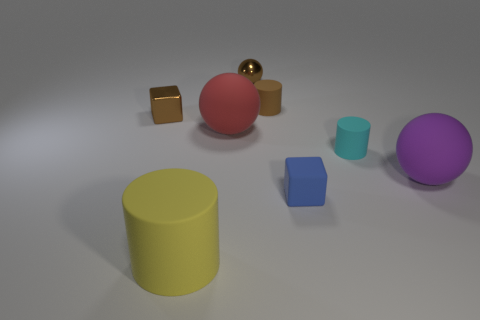Subtract all big red balls. How many balls are left? 2 Subtract 1 cylinders. How many cylinders are left? 2 Add 1 tiny brown rubber cylinders. How many objects exist? 9 Subtract all blue cylinders. Subtract all cyan spheres. How many cylinders are left? 3 Subtract all cubes. How many objects are left? 6 Add 6 big yellow metallic cylinders. How many big yellow metallic cylinders exist? 6 Subtract 0 green blocks. How many objects are left? 8 Subtract all purple objects. Subtract all large spheres. How many objects are left? 5 Add 6 purple matte things. How many purple matte things are left? 7 